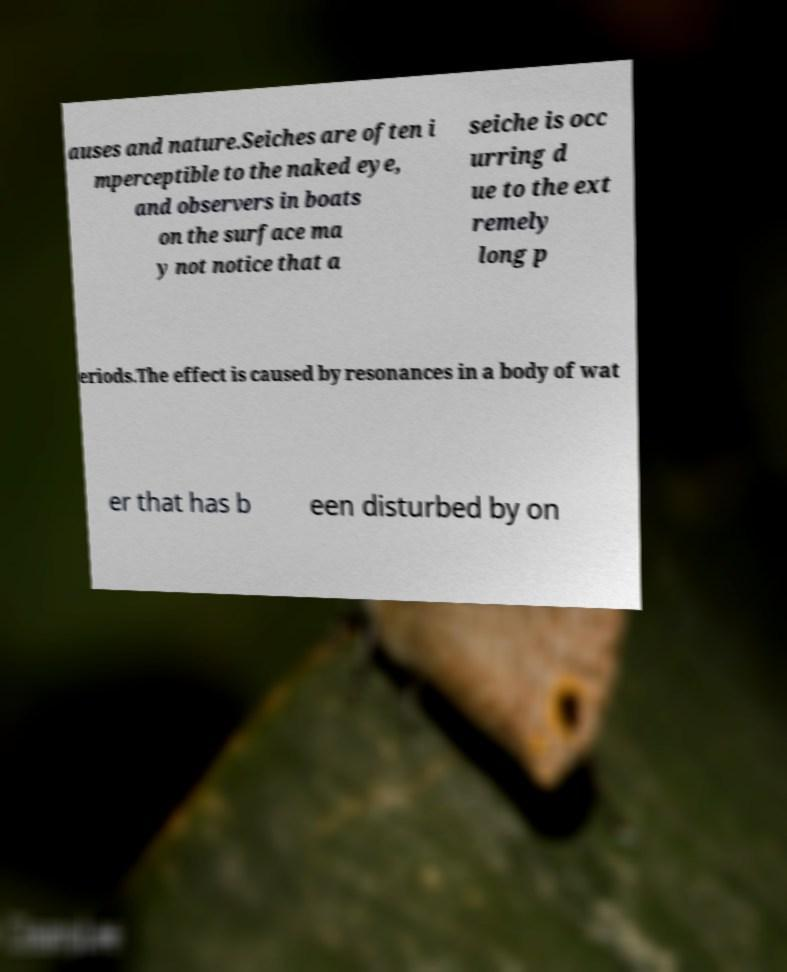What messages or text are displayed in this image? I need them in a readable, typed format. auses and nature.Seiches are often i mperceptible to the naked eye, and observers in boats on the surface ma y not notice that a seiche is occ urring d ue to the ext remely long p eriods.The effect is caused by resonances in a body of wat er that has b een disturbed by on 